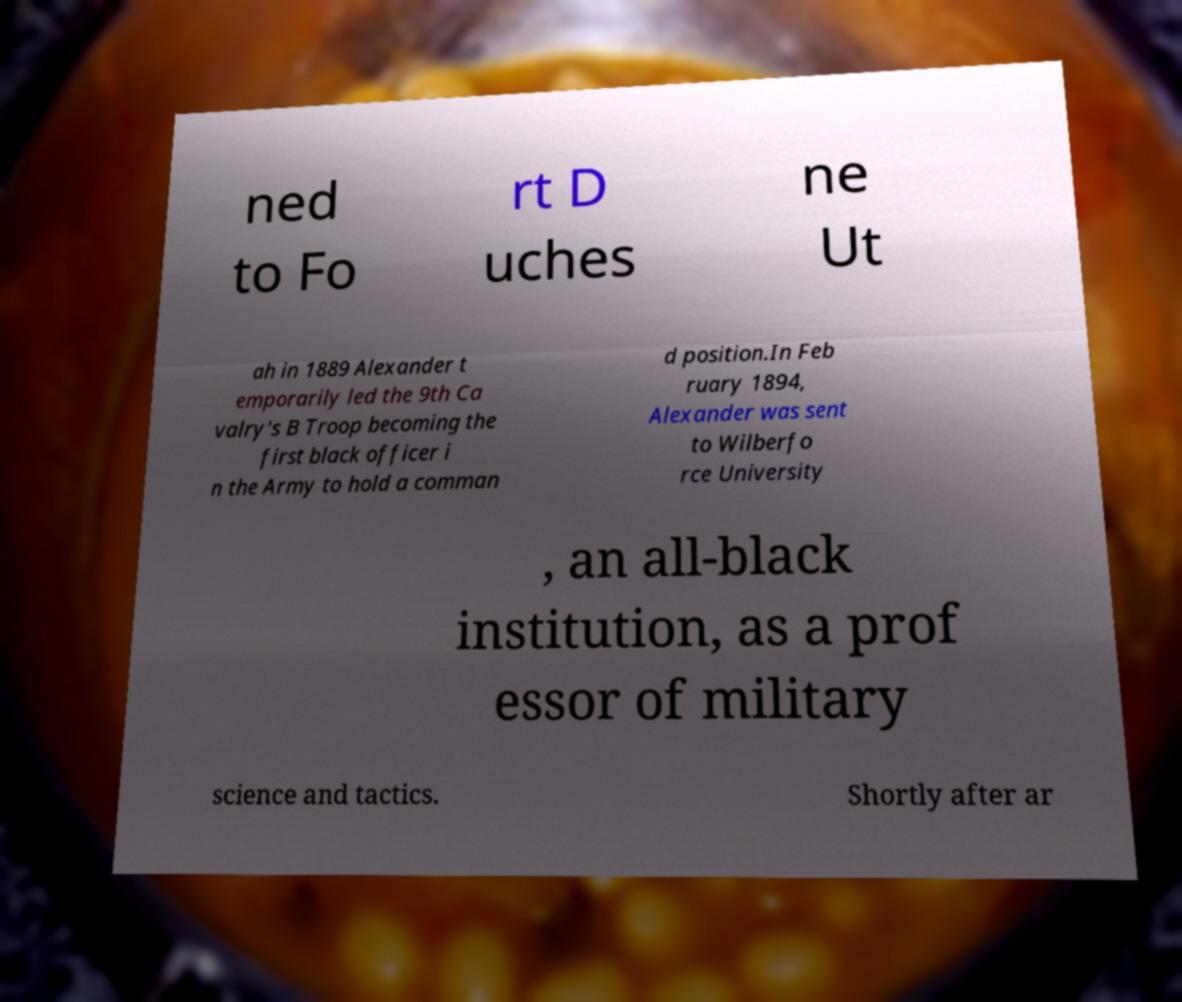Can you accurately transcribe the text from the provided image for me? ned to Fo rt D uches ne Ut ah in 1889 Alexander t emporarily led the 9th Ca valry's B Troop becoming the first black officer i n the Army to hold a comman d position.In Feb ruary 1894, Alexander was sent to Wilberfo rce University , an all-black institution, as a prof essor of military science and tactics. Shortly after ar 